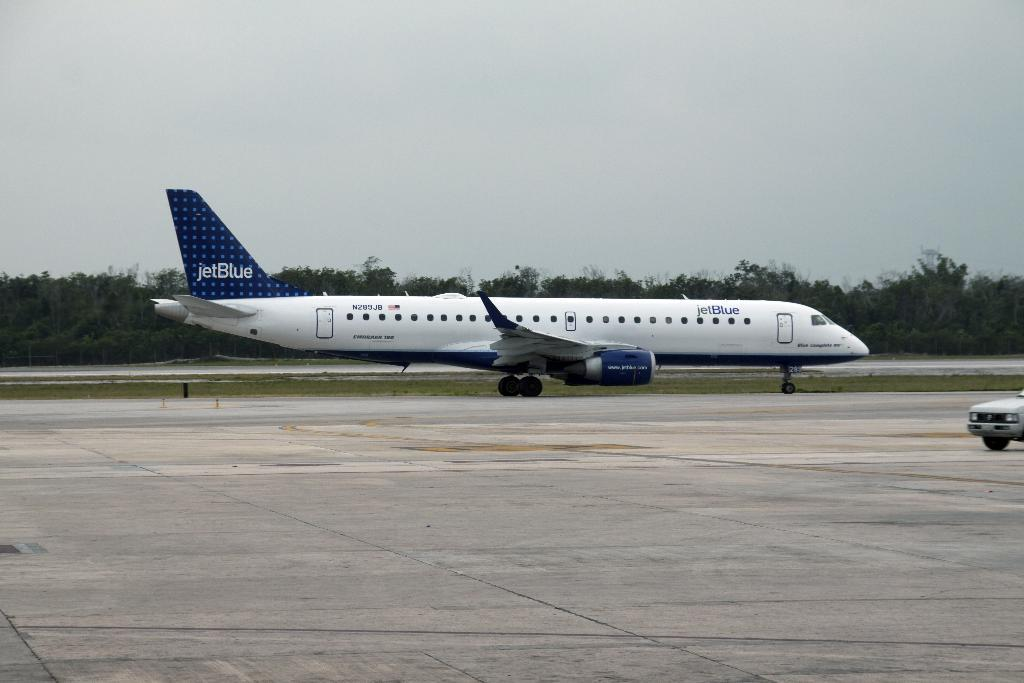What is written on the flight in the image? There is a flight with something written on it in the image, but the specific text is not mentioned in the facts. What can be seen in the background of the image? There are trees and sky visible in the background of the image. What type of vehicle is on the right side of the image? There is a car on the right side of the image. Where is the bucket located in the image? There is no bucket present in the image. What type of coast can be seen in the image? There is no coast visible in the image. 